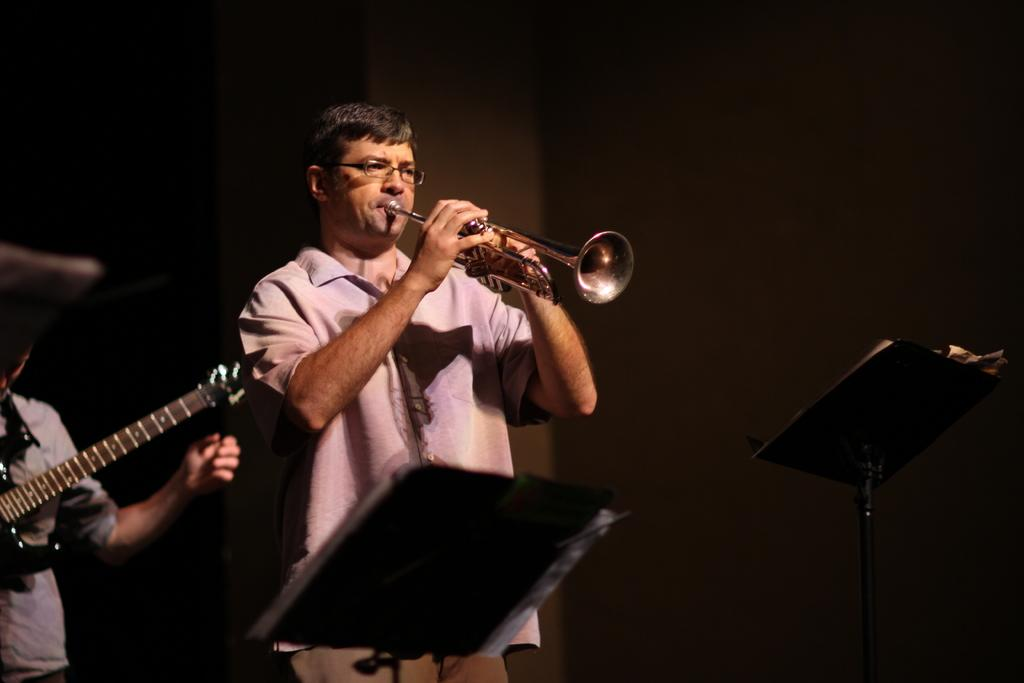How many people are in the image? There are two men in the image. What are the men doing in the image? The men are playing musical instruments. Can you describe any additional objects in the image? There is a notepad stand in front of the men. What type of tin can be seen in the image? There is no tin present in the image. Is there a cannon visible in the image? No, there is no cannon in the image. Can you describe the potato in the image? There is no potato present in the image. 